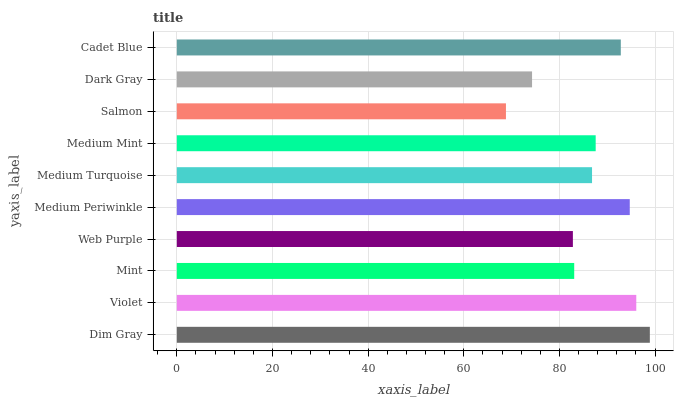Is Salmon the minimum?
Answer yes or no. Yes. Is Dim Gray the maximum?
Answer yes or no. Yes. Is Violet the minimum?
Answer yes or no. No. Is Violet the maximum?
Answer yes or no. No. Is Dim Gray greater than Violet?
Answer yes or no. Yes. Is Violet less than Dim Gray?
Answer yes or no. Yes. Is Violet greater than Dim Gray?
Answer yes or no. No. Is Dim Gray less than Violet?
Answer yes or no. No. Is Medium Mint the high median?
Answer yes or no. Yes. Is Medium Turquoise the low median?
Answer yes or no. Yes. Is Medium Turquoise the high median?
Answer yes or no. No. Is Medium Mint the low median?
Answer yes or no. No. 